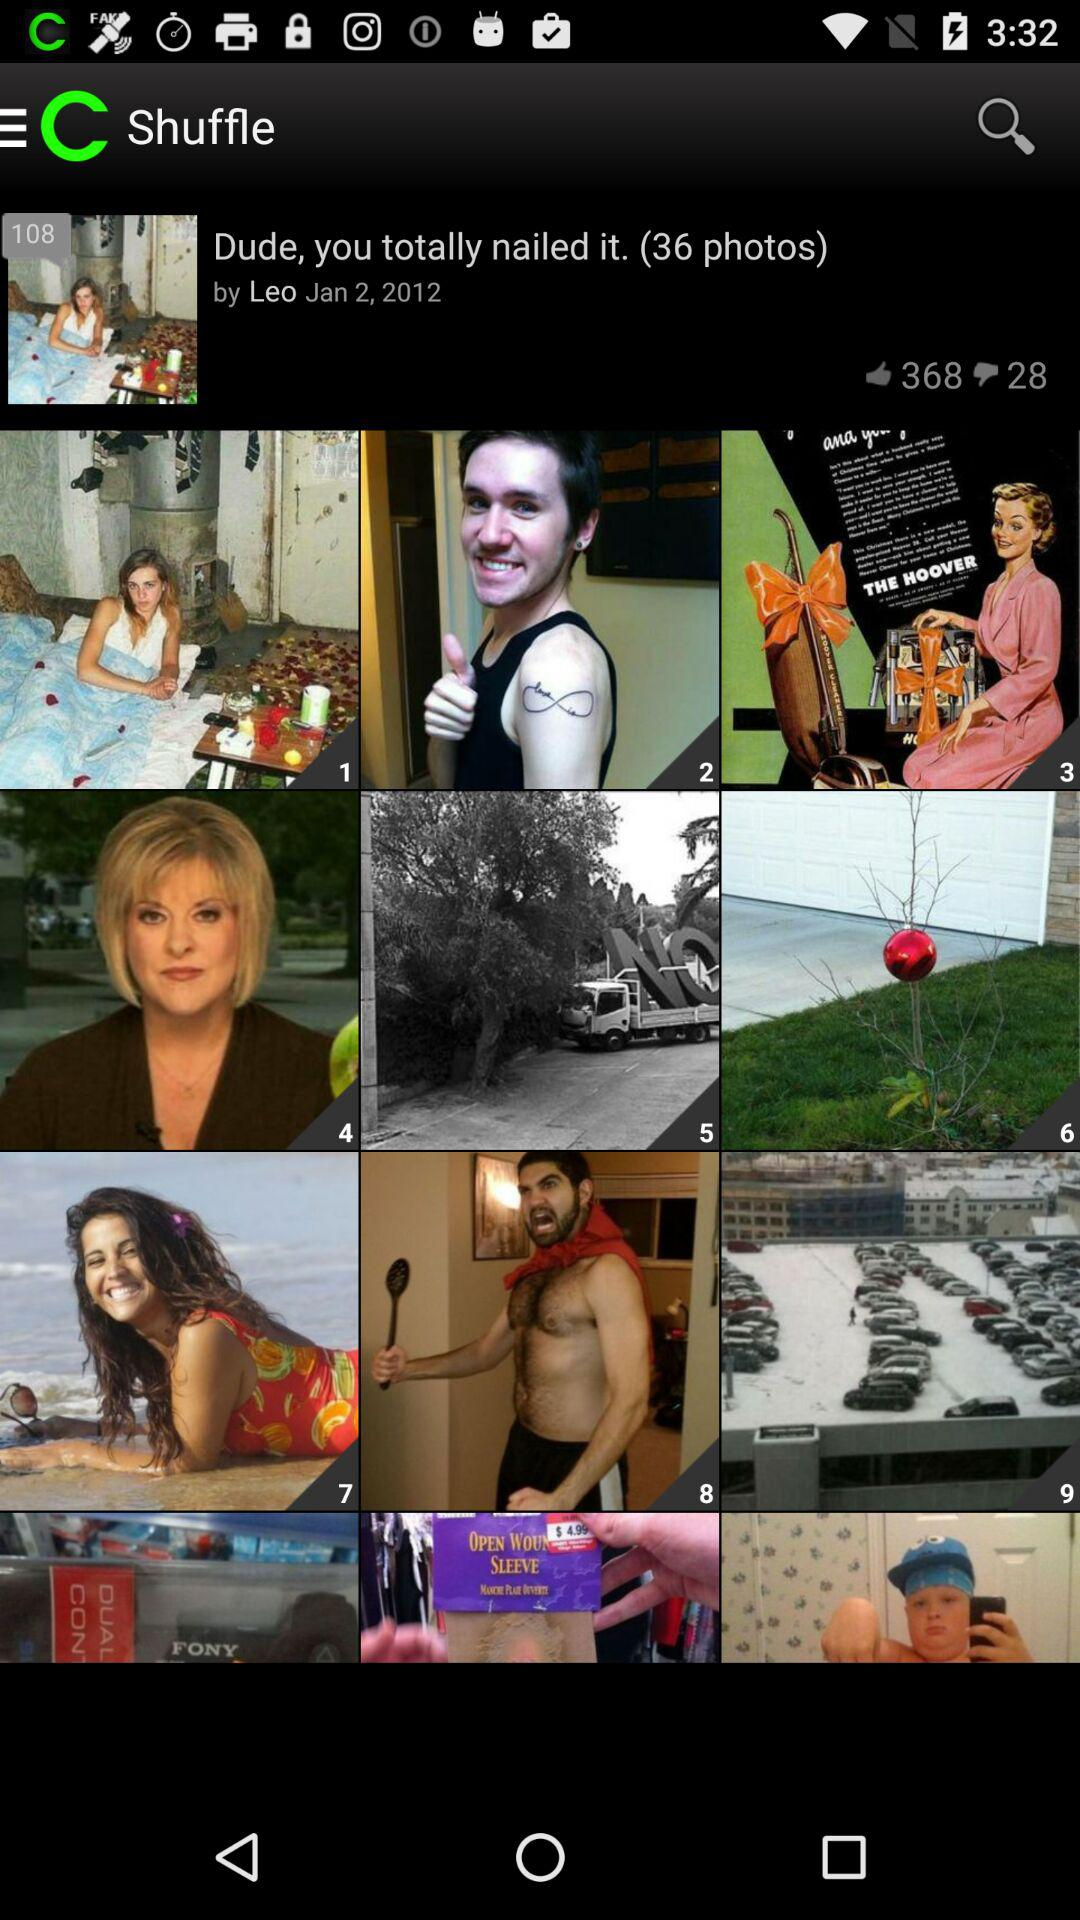How many likes are there? There are 368 likes. 